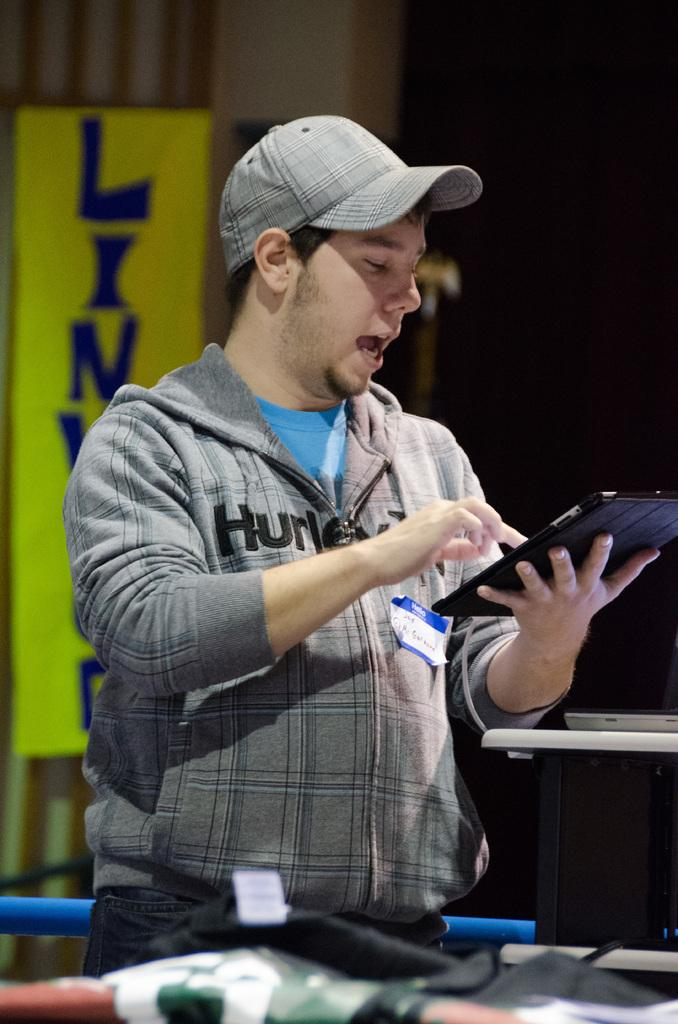Who is the main subject in the image? There is a man in the picture. What is the man doing in the image? The man is standing and operating a gadget. What can be seen behind the man in the image? There is a banner behind the man. What type of maid is visible in the image? There is no maid present in the image. What event is taking place in the image? The provided facts do not mention any specific event taking place in the image. 